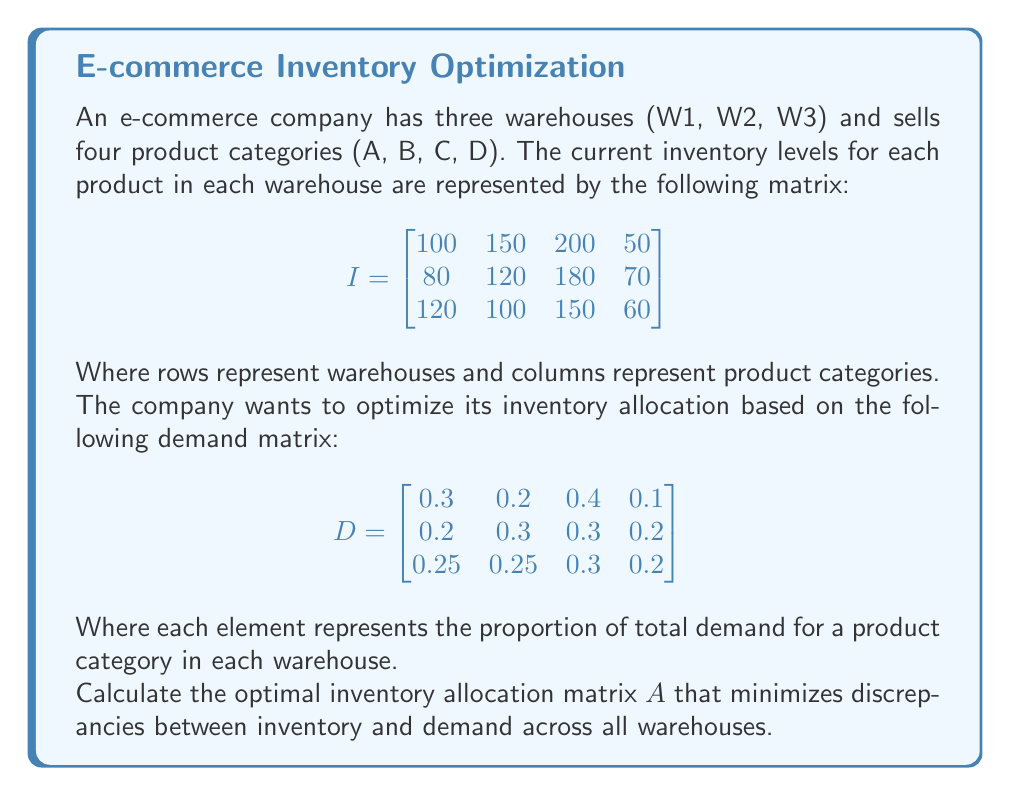Show me your answer to this math problem. To find the optimal inventory allocation matrix $A$, we need to follow these steps:

1) First, calculate the total inventory for each product category:
   $$T = \begin{bmatrix} 300 & 370 & 530 & 180 \end{bmatrix}$$

2) Now, we can calculate the optimal allocation matrix $A$ by multiplying the demand matrix $D$ by the total inventory for each product:

   $$A = D \cdot \text{diag}(T)$$

   Where $\text{diag}(T)$ is a diagonal matrix with the elements of $T$ on its main diagonal.

3) Let's perform this calculation:

   $$\begin{bmatrix}
   0.3 & 0.2 & 0.4 & 0.1 \\
   0.2 & 0.3 & 0.3 & 0.2 \\
   0.25 & 0.25 & 0.3 & 0.2
   \end{bmatrix} \cdot 
   \begin{bmatrix}
   300 & 0 & 0 & 0 \\
   0 & 370 & 0 & 0 \\
   0 & 0 & 530 & 0 \\
   0 & 0 & 0 & 180
   \end{bmatrix}$$

4) Multiplying these matrices:

   $$A = \begin{bmatrix}
   90 & 74 & 212 & 18 \\
   60 & 111 & 159 & 36 \\
   75 & 92.5 & 159 & 36
   \end{bmatrix}$$

This matrix $A$ represents the optimal inventory allocation across warehouses for each product category, based on the given demand proportions.
Answer: $$A = \begin{bmatrix}
90 & 74 & 212 & 18 \\
60 & 111 & 159 & 36 \\
75 & 92.5 & 159 & 36
\end{bmatrix}$$ 